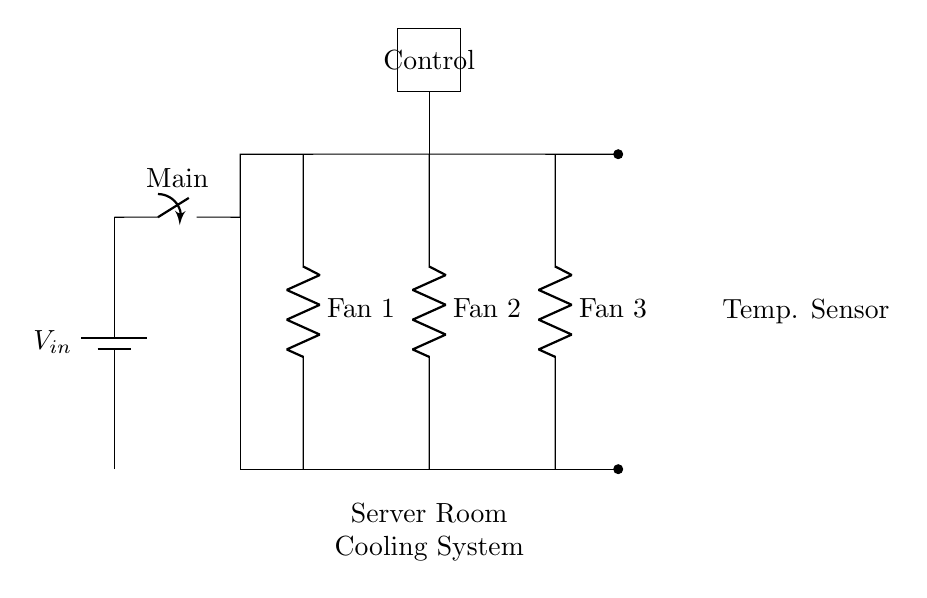What are the components used in this circuit? The circuit features a battery, main switch, three fans, a temperature sensor, and a control unit.
Answer: battery, switch, fans, temperature sensor, control unit What is the function of the temperature sensor? The temperature sensor monitors the temperature within the server room and helps regulate the operation of the cooling fans to maintain optimal conditions.
Answer: temperature monitoring How many fans are connected in parallel? There are three fans connected in parallel to ensure they all receive the same voltage from the power supply while allowing them to operate independently.
Answer: three What role does the control unit play in this circuit? The control unit manages the operational aspects of the fans based on inputs from the temperature sensor, enabling it to turn fans on or off as needed.
Answer: fan control What is the advantage of using a parallel circuit for the fans? Using a parallel configuration allows each fan to operate independently while receiving the same voltage supply, providing redundancy; if one fan fails, the others continue to function.
Answer: redundancy 